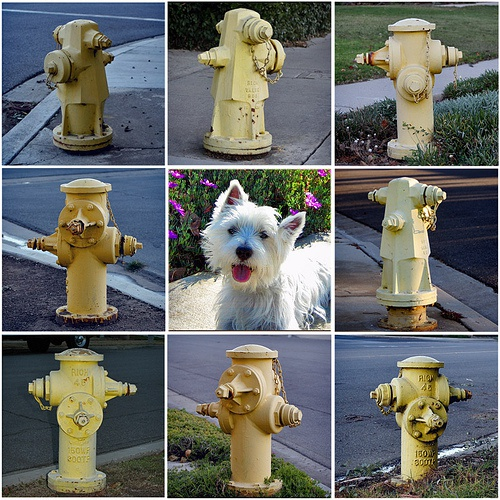Describe the objects in this image and their specific colors. I can see dog in white, darkgray, and gray tones, fire hydrant in white, tan, and gray tones, fire hydrant in white, olive, and tan tones, fire hydrant in white, olive, tan, and darkgray tones, and fire hydrant in white, tan, darkgray, and black tones in this image. 